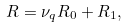<formula> <loc_0><loc_0><loc_500><loc_500>R = \nu _ { q } R _ { 0 } + R _ { 1 } ,</formula> 